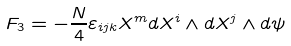<formula> <loc_0><loc_0><loc_500><loc_500>F _ { 3 } = - \frac { N } { 4 } \varepsilon _ { i j k } X ^ { m } d X ^ { i } \wedge d X ^ { j } \wedge d \psi</formula> 